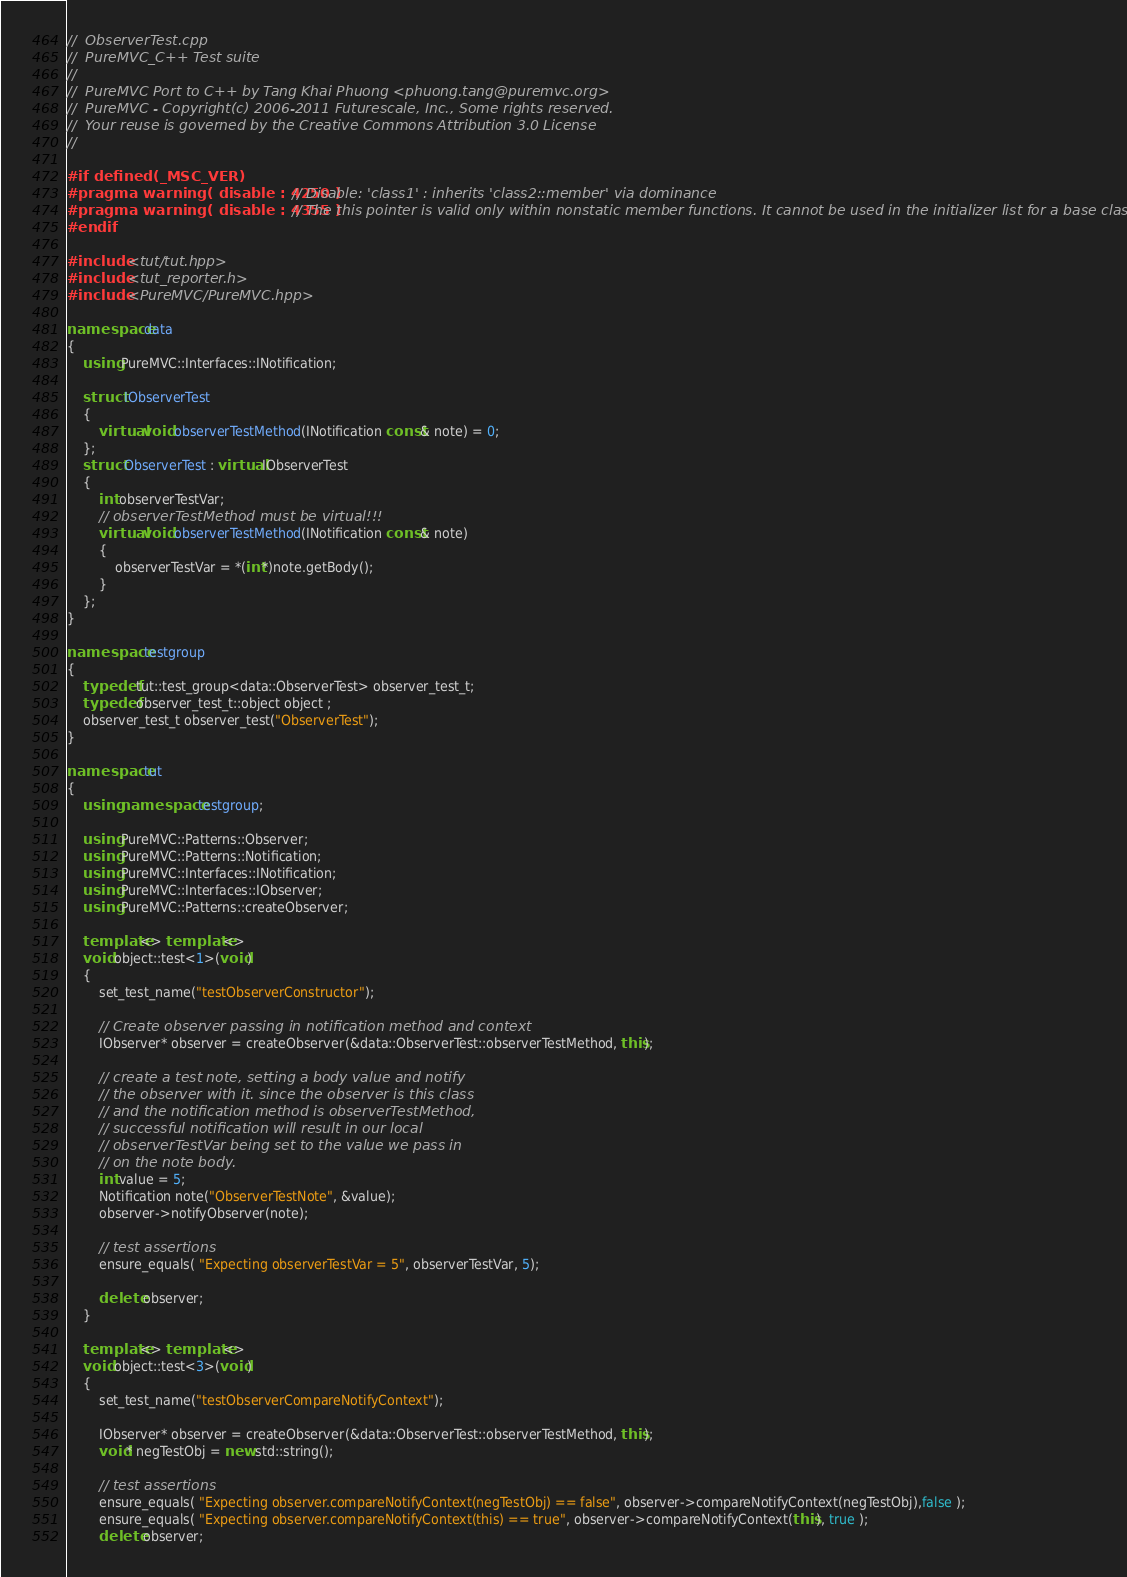Convert code to text. <code><loc_0><loc_0><loc_500><loc_500><_C++_>//  ObserverTest.cpp
//  PureMVC_C++ Test suite
//
//  PureMVC Port to C++ by Tang Khai Phuong <phuong.tang@puremvc.org>
//  PureMVC - Copyright(c) 2006-2011 Futurescale, Inc., Some rights reserved.
//  Your reuse is governed by the Creative Commons Attribution 3.0 License
//

#if defined(_MSC_VER)
#pragma warning( disable : 4250 ) // Disable: 'class1' : inherits 'class2::member' via dominance
#pragma warning( disable : 4355 ) // The this pointer is valid only within nonstatic member functions. It cannot be used in the initializer list for a base class.ck(16)
#endif

#include <tut/tut.hpp>
#include <tut_reporter.h>
#include <PureMVC/PureMVC.hpp>

namespace data
{
    using PureMVC::Interfaces::INotification;

    struct IObserverTest
    {
        virtual void observerTestMethod(INotification const& note) = 0;
    };
    struct ObserverTest : virtual IObserverTest
    {
        int observerTestVar;
        // observerTestMethod must be virtual!!! 
        virtual void observerTestMethod(INotification const& note)
        {
            observerTestVar = *(int*)note.getBody();
        }
    };
}

namespace testgroup
{
    typedef tut::test_group<data::ObserverTest> observer_test_t;
    typedef observer_test_t::object object ;
    observer_test_t observer_test("ObserverTest");
}

namespace tut
{
    using namespace testgroup;

    using PureMVC::Patterns::Observer;
    using PureMVC::Patterns::Notification;
    using PureMVC::Interfaces::INotification;
    using PureMVC::Interfaces::IObserver;
    using PureMVC::Patterns::createObserver;

    template<> template<> 
    void object::test<1>(void)
    {
        set_test_name("testObserverConstructor");

        // Create observer passing in notification method and context
        IObserver* observer = createObserver(&data::ObserverTest::observerTestMethod, this);

        // create a test note, setting a body value and notify 
        // the observer with it. since the observer is this class 
        // and the notification method is observerTestMethod,
        // successful notification will result in our local 
        // observerTestVar being set to the value we pass in 
        // on the note body.
        int value = 5;
        Notification note("ObserverTestNote", &value);
        observer->notifyObserver(note);

        // test assertions
        ensure_equals( "Expecting observerTestVar = 5", observerTestVar, 5);

        delete observer;
    }

    template<> template<> 
    void object::test<3>(void)
    {
        set_test_name("testObserverCompareNotifyContext");

        IObserver* observer = createObserver(&data::ObserverTest::observerTestMethod, this);
        void* negTestObj = new std::string();

        // test assertions
        ensure_equals( "Expecting observer.compareNotifyContext(negTestObj) == false", observer->compareNotifyContext(negTestObj),false );
        ensure_equals( "Expecting observer.compareNotifyContext(this) == true", observer->compareNotifyContext(this), true );
        delete observer;</code> 